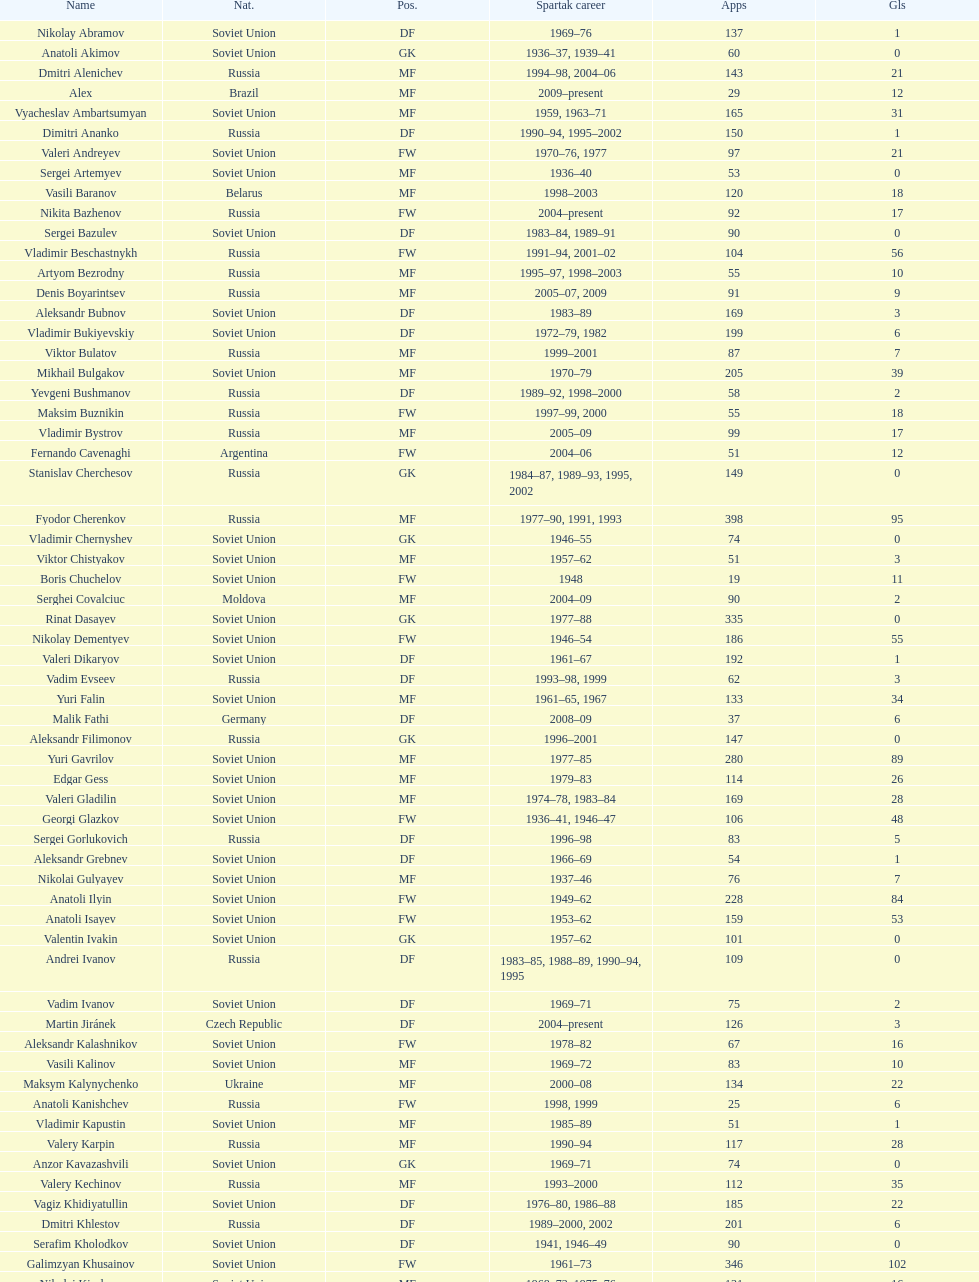How many players had at least 20 league goals scored? 56. 